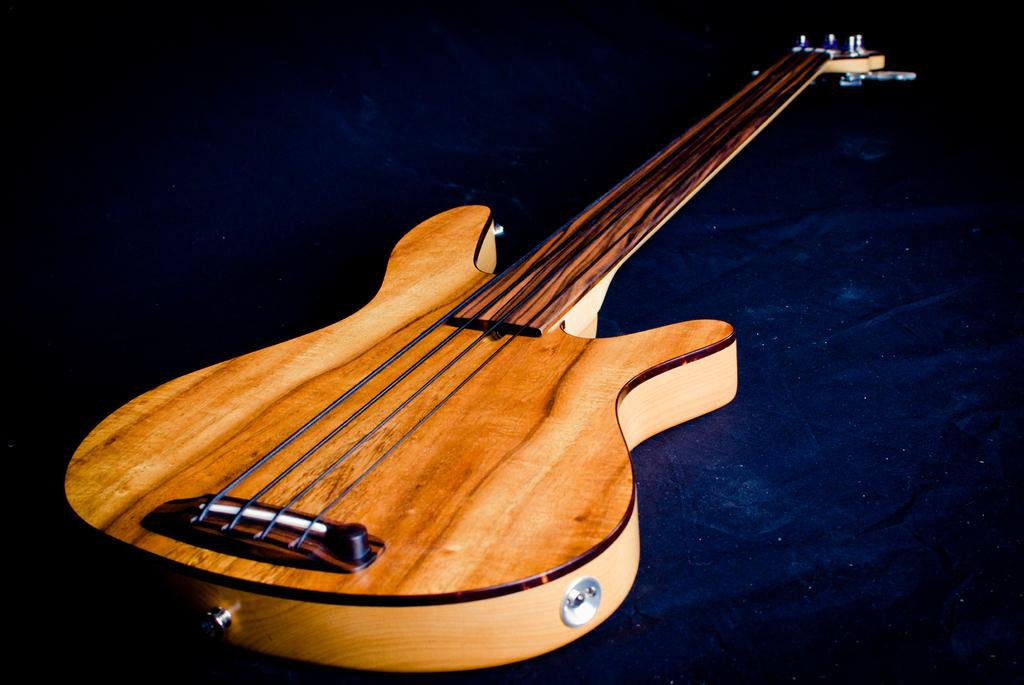What type of musical instrument is in the image? There is a wooden guitar in the image. What feature of the guitar is mentioned in the facts? The guitar has strings. Where is the guitar located in the image? The guitar is placed on the floor. What else can be seen near the guitar? There is a cloth near the guitar. What color are the fairies flying around the guitar in the image? There are no fairies present in the image; it only features a wooden guitar with strings, placed on the floor, and a cloth nearby. 